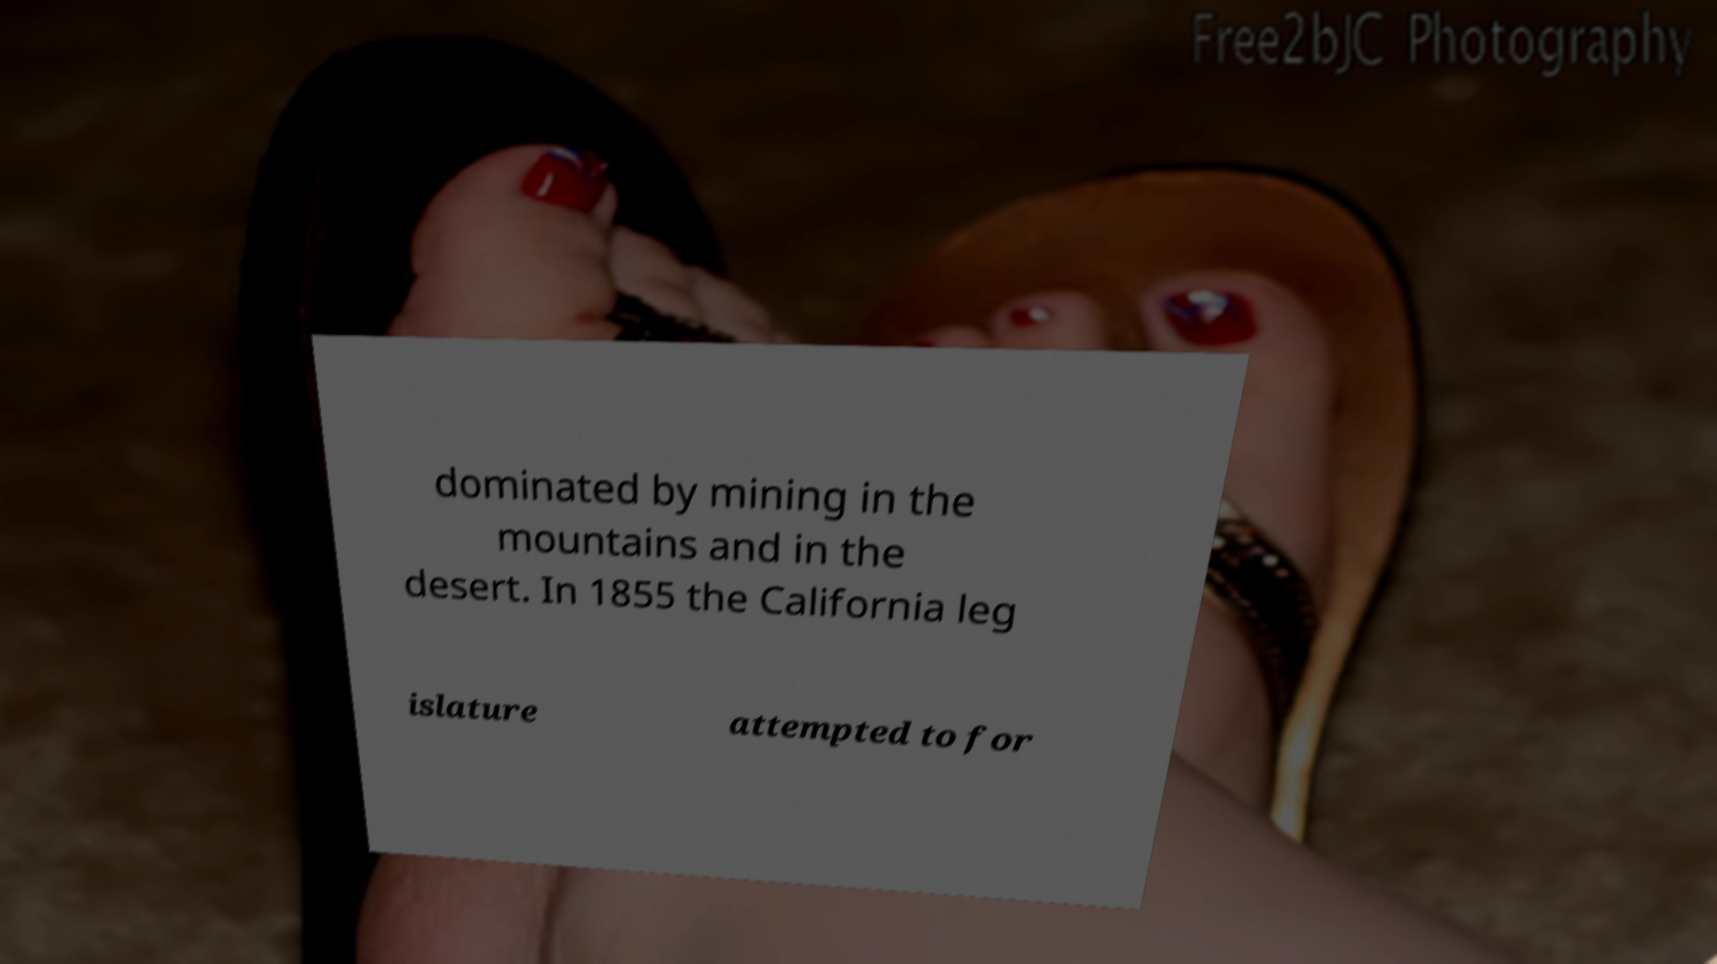For documentation purposes, I need the text within this image transcribed. Could you provide that? dominated by mining in the mountains and in the desert. In 1855 the California leg islature attempted to for 